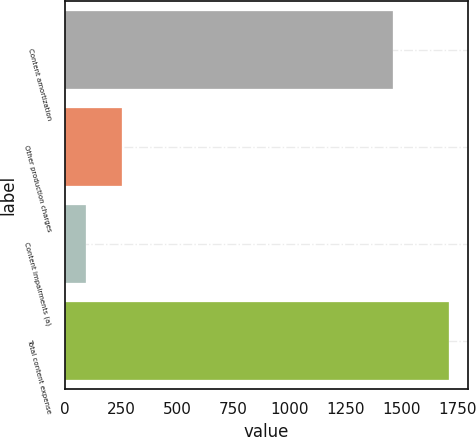Convert chart to OTSL. <chart><loc_0><loc_0><loc_500><loc_500><bar_chart><fcel>Content amortization<fcel>Other production charges<fcel>Content impairments (a)<fcel>Total content expense<nl><fcel>1462<fcel>256.7<fcel>95<fcel>1712<nl></chart> 